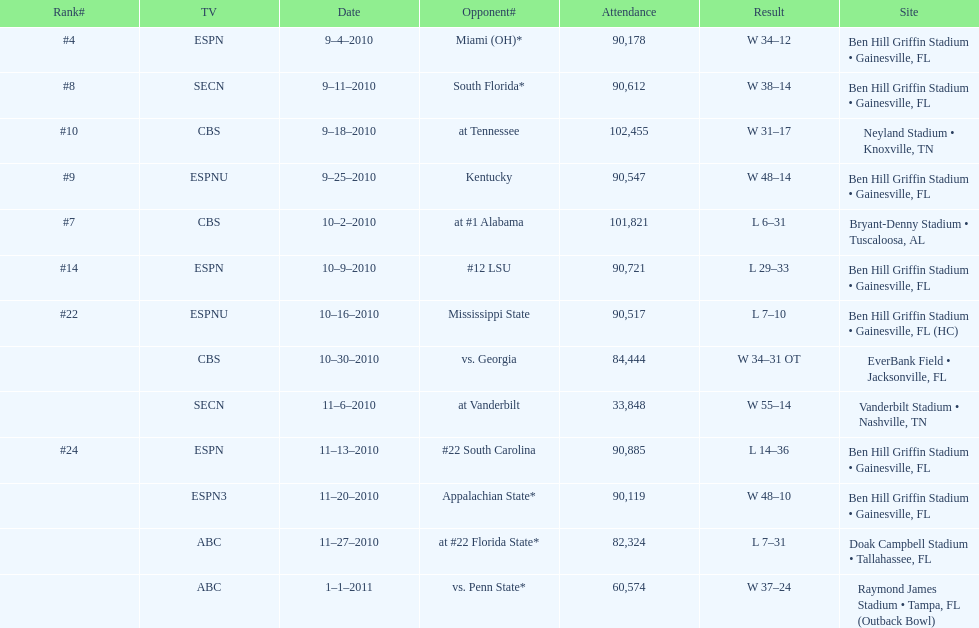How many games were played at the ben hill griffin stadium during the 2010-2011 season? 7. 